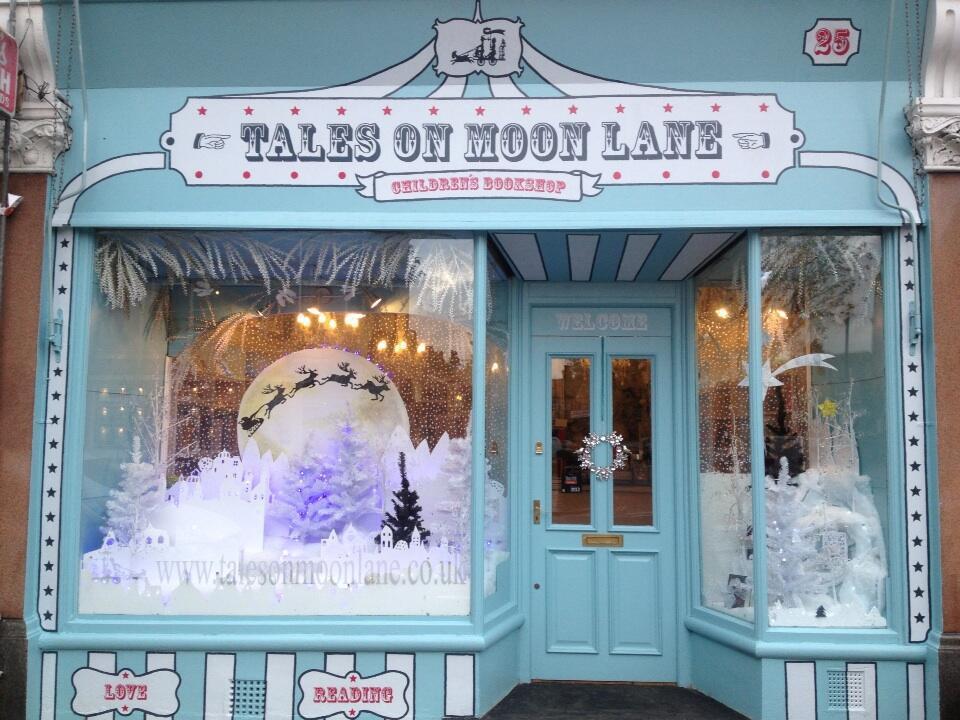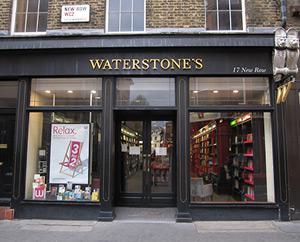The first image is the image on the left, the second image is the image on the right. For the images displayed, is the sentence "One of the images features a light blue storefront that has a moon on display." factually correct? Answer yes or no. Yes. The first image is the image on the left, the second image is the image on the right. Considering the images on both sides, is "in both images, the storefronts show the store name on them" valid? Answer yes or no. Yes. 